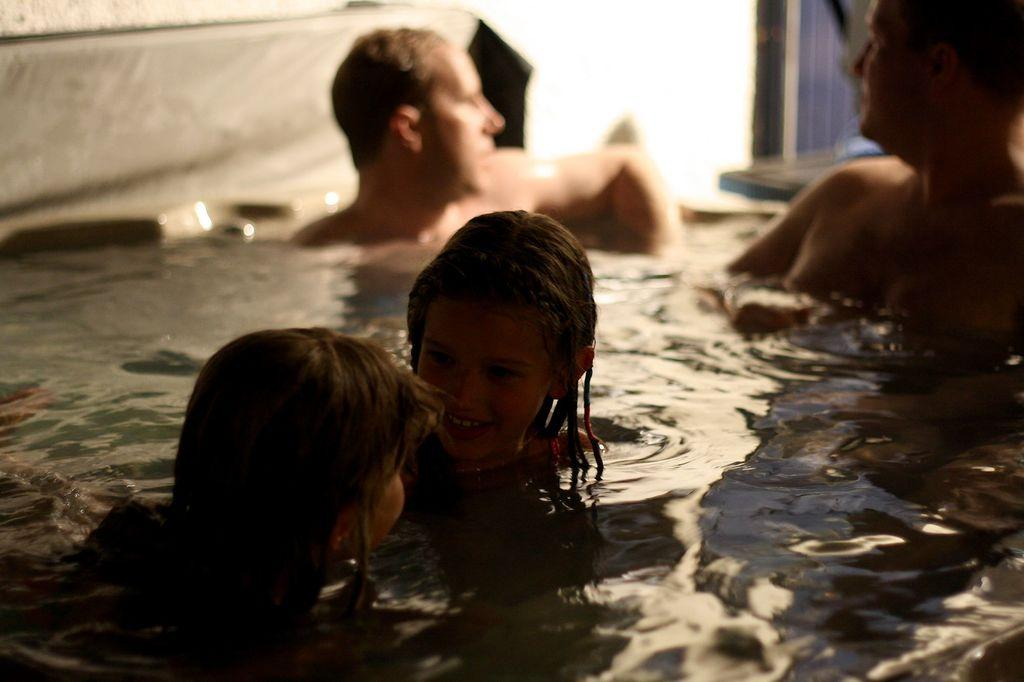What are the people in the image doing? The people in the image are in the water. What can be seen in the background of the image? There is a wall in the background of the image. Where are the rabbits hopping in the image? There are no rabbits present in the image. What type of sticks are being used by the people in the water? There is no indication of sticks being used by the people in the water in the image. 